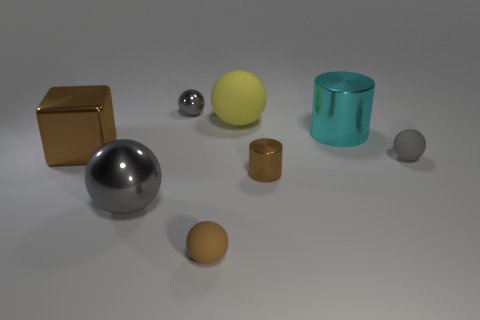Subtract all red cylinders. How many gray balls are left? 3 Subtract all large gray spheres. How many spheres are left? 4 Subtract all yellow balls. How many balls are left? 4 Subtract 2 spheres. How many spheres are left? 3 Add 1 tiny brown spheres. How many objects exist? 9 Subtract all red balls. Subtract all cyan cylinders. How many balls are left? 5 Subtract all balls. How many objects are left? 3 Add 5 big brown metallic blocks. How many big brown metallic blocks are left? 6 Add 6 cyan spheres. How many cyan spheres exist? 6 Subtract 0 blue cylinders. How many objects are left? 8 